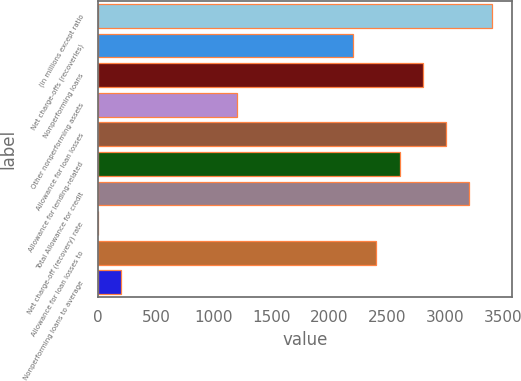Convert chart. <chart><loc_0><loc_0><loc_500><loc_500><bar_chart><fcel>(in millions except ratio<fcel>Net charge-offs (recoveries)<fcel>Nonperforming loans<fcel>Other nonperforming assets<fcel>Allowance for loan losses<fcel>Allowance for lending-related<fcel>Total Allowance for credit<fcel>Net charge-off (recovery) rate<fcel>Allowance for loan losses to<fcel>Nonperforming loans to average<nl><fcel>3408.27<fcel>2205.45<fcel>2806.86<fcel>1203.1<fcel>3007.33<fcel>2606.39<fcel>3207.8<fcel>0.28<fcel>2405.92<fcel>200.75<nl></chart> 